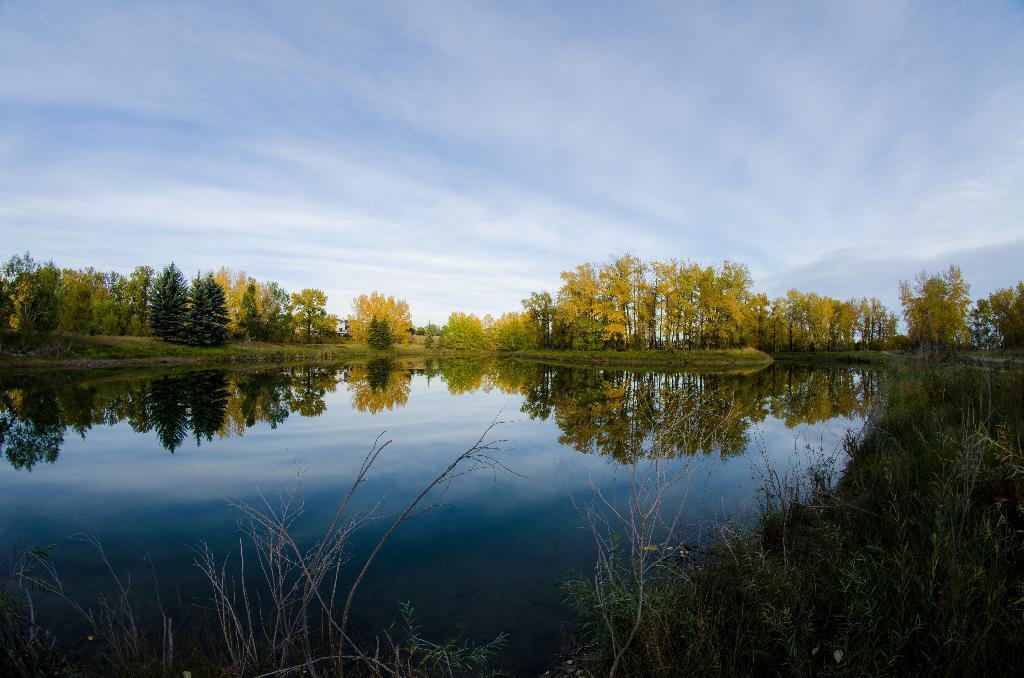Please provide a concise description of this image. In this image there is a lake, on the bottom right there are plants, in the background there are trees and the sky. 